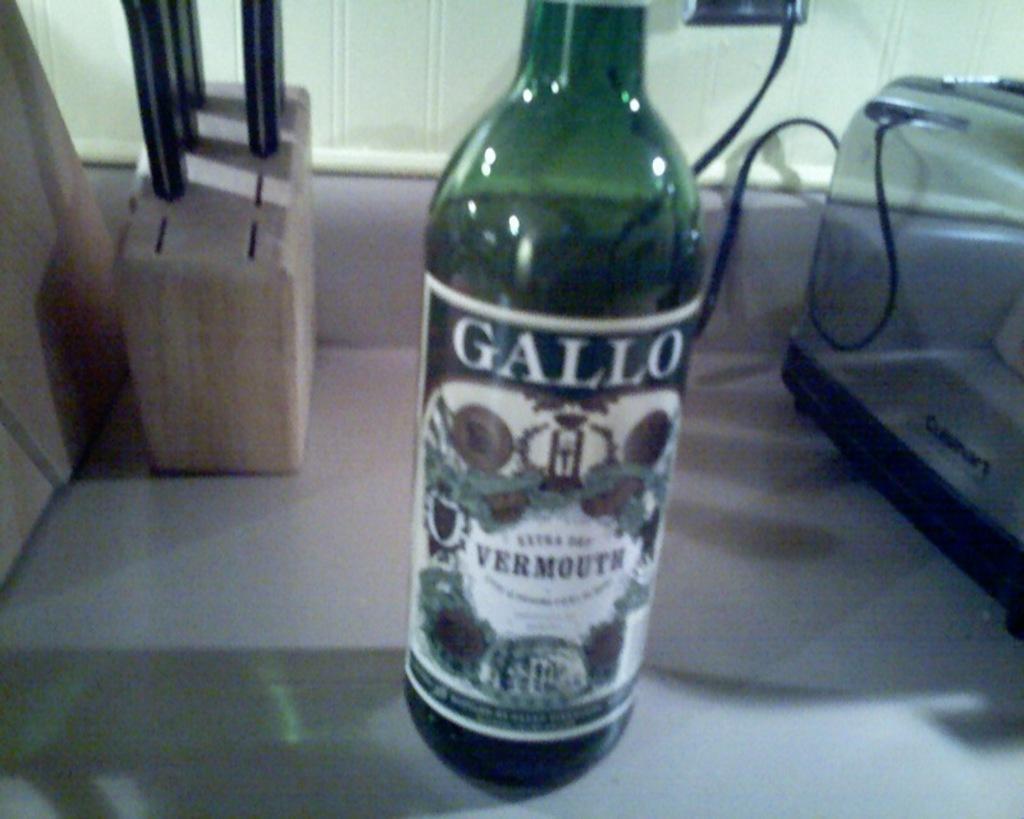Describe this image in one or two sentences. This bottle is highlighted in this picture. On this bottle there is a sticker. Beside this bottle there is a knife holder and toast maker. 